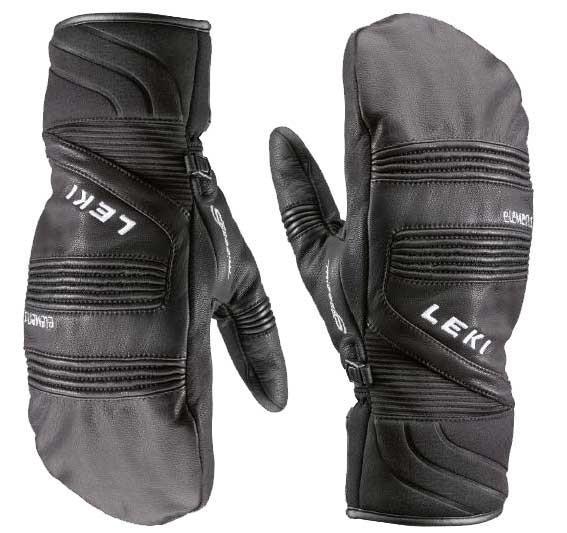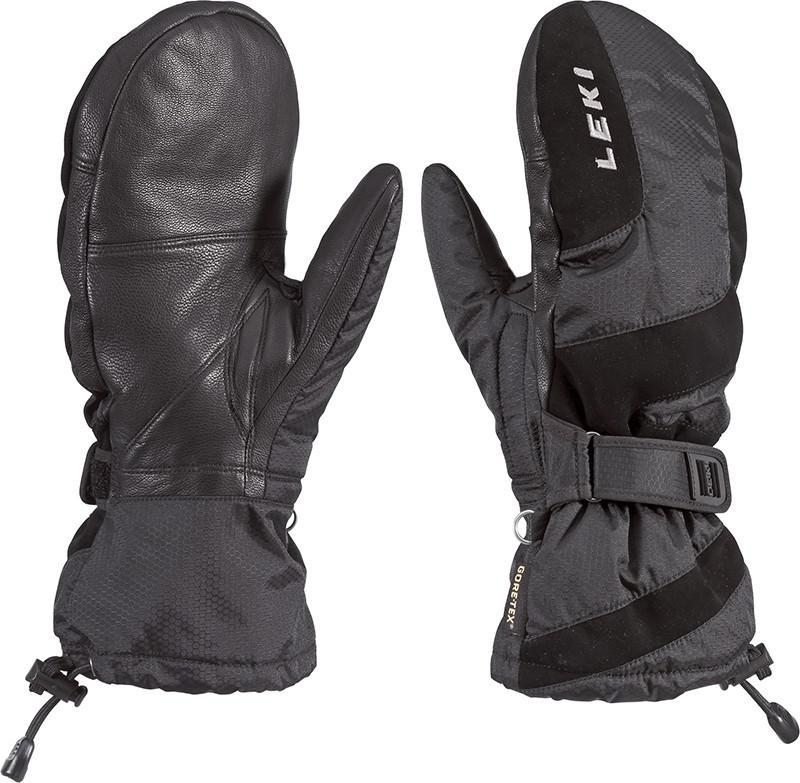The first image is the image on the left, the second image is the image on the right. Analyze the images presented: Is the assertion "Each image shows the front and back of a pair of black mittens with no individual fingers, and no pair of mittens has overlapping individual mittens." valid? Answer yes or no. Yes. 